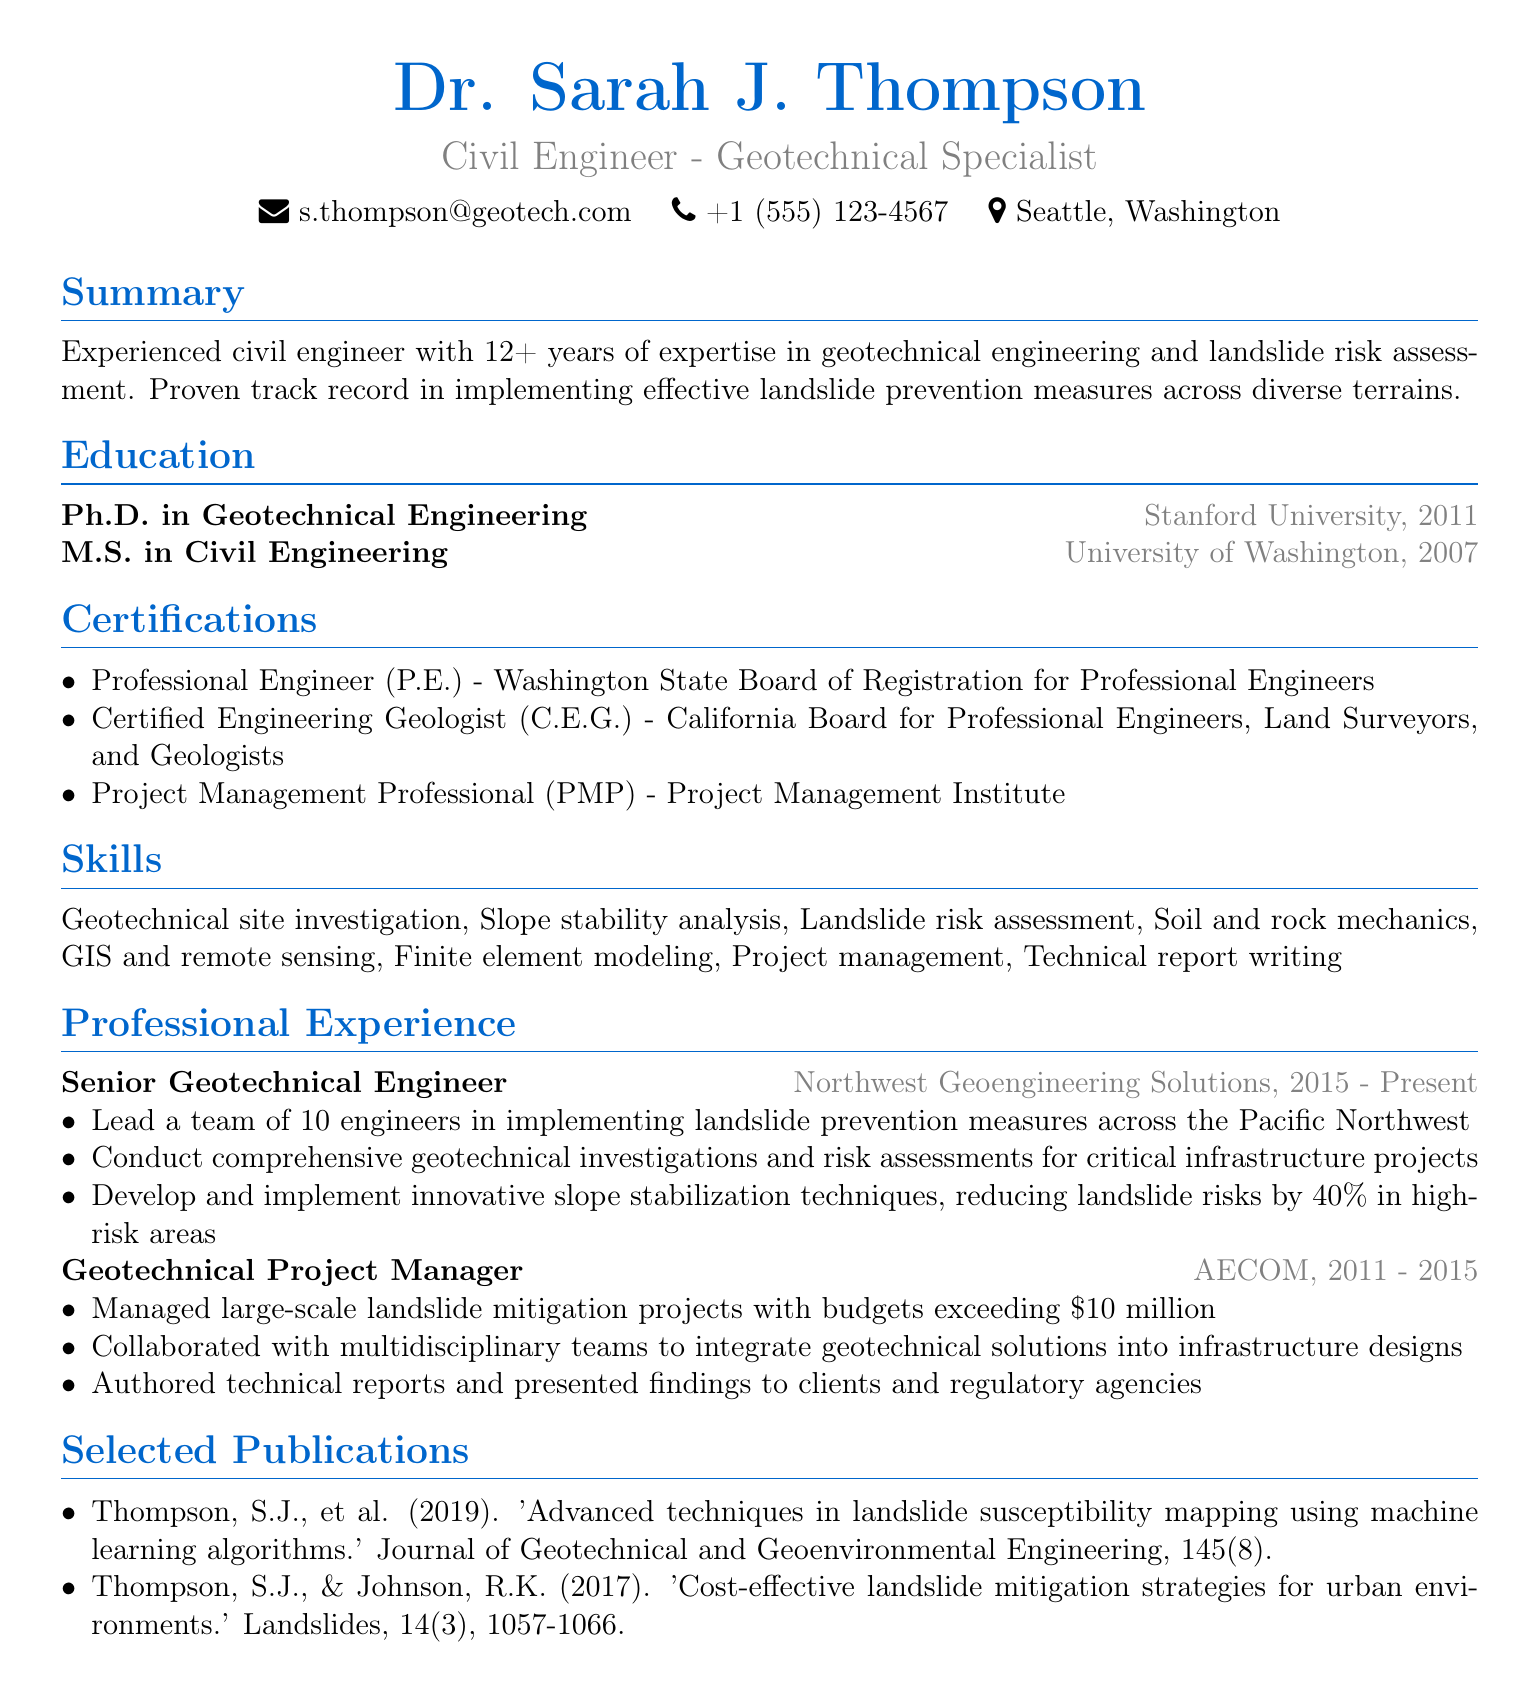what is the name of the civil engineer? The document specifies the name of the civil engineer, which is prominently mentioned at the beginning.
Answer: Dr. Sarah J. Thompson what is the highest degree obtained? The highest degree is listed under the education section of the document, specifying the Ph.D. degree.
Answer: Ph.D. in Geotechnical Engineering which certification is related to project management? The certifications section includes various credentials, one of which pertains to project management.
Answer: Project Management Professional (PMP) how many years of experience does the engineer have? The summary section provides a specific number of years of expertise in geotechnical engineering and landslide risk assessment.
Answer: 12+ what is the role of the engineer at Northwest Geoengineering Solutions? The professional experience section details the engineer's current job title and responsibilities within this company.
Answer: Senior Geotechnical Engineer how much budget did the projects managed at AECOM exceed? The professional experience section mentions the budget amounts managed for projects, giving a specific figure.
Answer: $10 million what innovative technique was developed to reduce landslide risks? In the responsibilities listed for the Senior Geotechnical Engineer, an innovative technique that contributed to risk reduction is mentioned.
Answer: Slope stabilization techniques name one publication by Dr. Sarah J. Thompson. The selected publications section lists the author's works, and a title can be extracted.
Answer: Advanced techniques in landslide susceptibility mapping using machine learning algorithms 